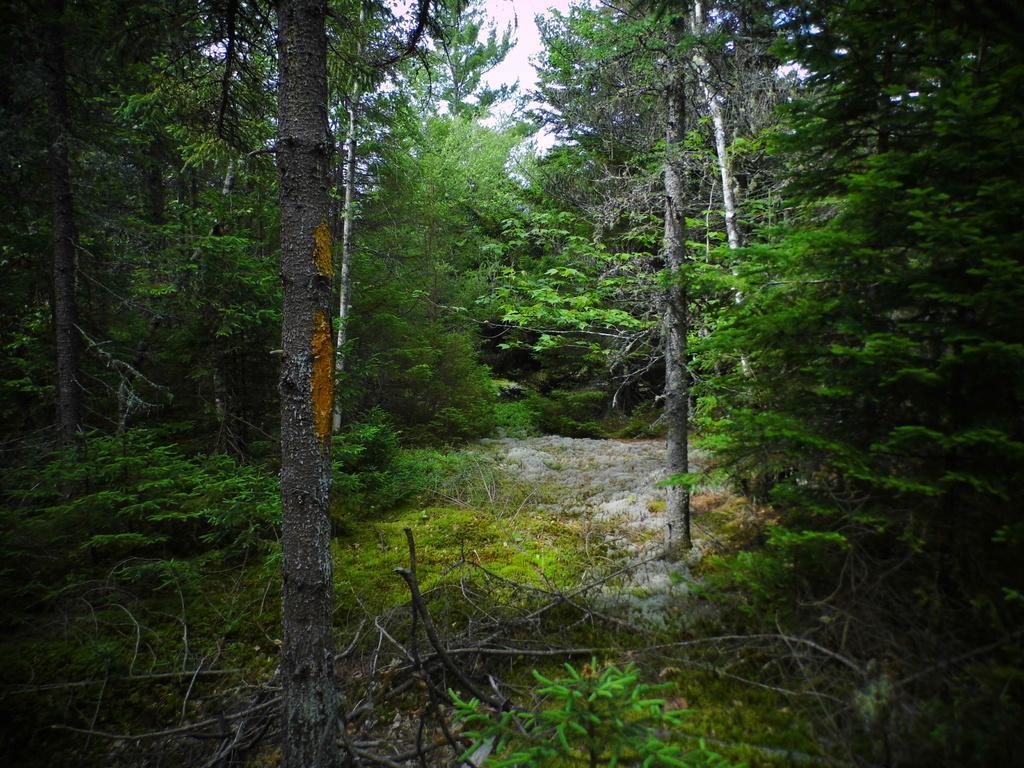Could you give a brief overview of what you see in this image? In this image there are trees, plants and grass on the ground. In the center there is a path. At the top there is the sky. At the bottom there are dried stems on the ground. 